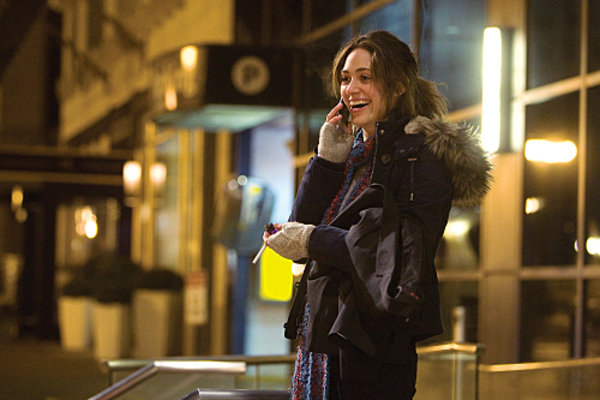Explain the visual content of the image in great detail. The image captures a woman in a lively urban night setting. She is engaged in a phone conversation, smiling brightly which suggests she is enjoying the conversation. Her winter attire includes a dark coat with a fur-lined hood and a knitted multicolored scarf, indicating it's likely a cold day. Her gloves appear handmade, adding a personal touch to her outfit. Behind her, the glow of the urban lights and a softly illuminated sign on a building provide a busy city backdrop, contributing to the scene's lively, nocturnal atmosphere. 